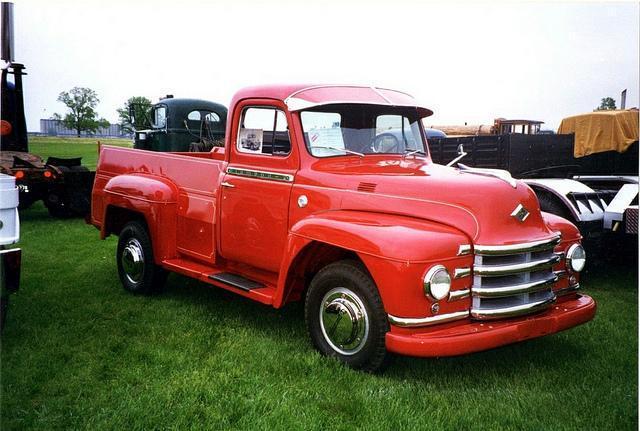How many brake lights are in this photo?
Give a very brief answer. 2. How many trucks are in the photo?
Give a very brief answer. 4. How many cows are facing the ocean?
Give a very brief answer. 0. 